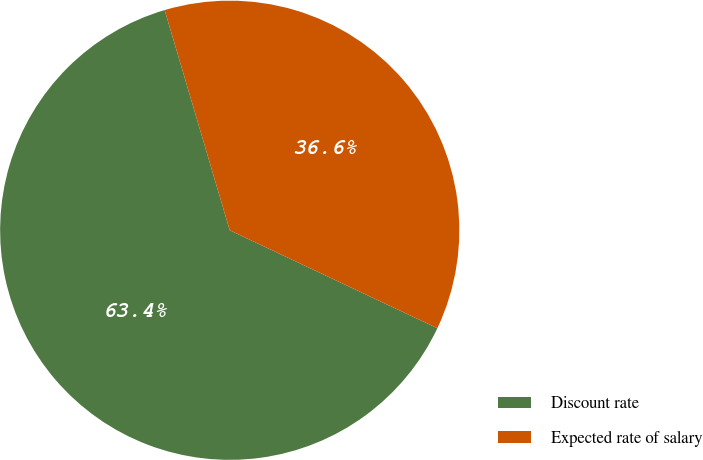Convert chart to OTSL. <chart><loc_0><loc_0><loc_500><loc_500><pie_chart><fcel>Discount rate<fcel>Expected rate of salary<nl><fcel>63.41%<fcel>36.59%<nl></chart> 